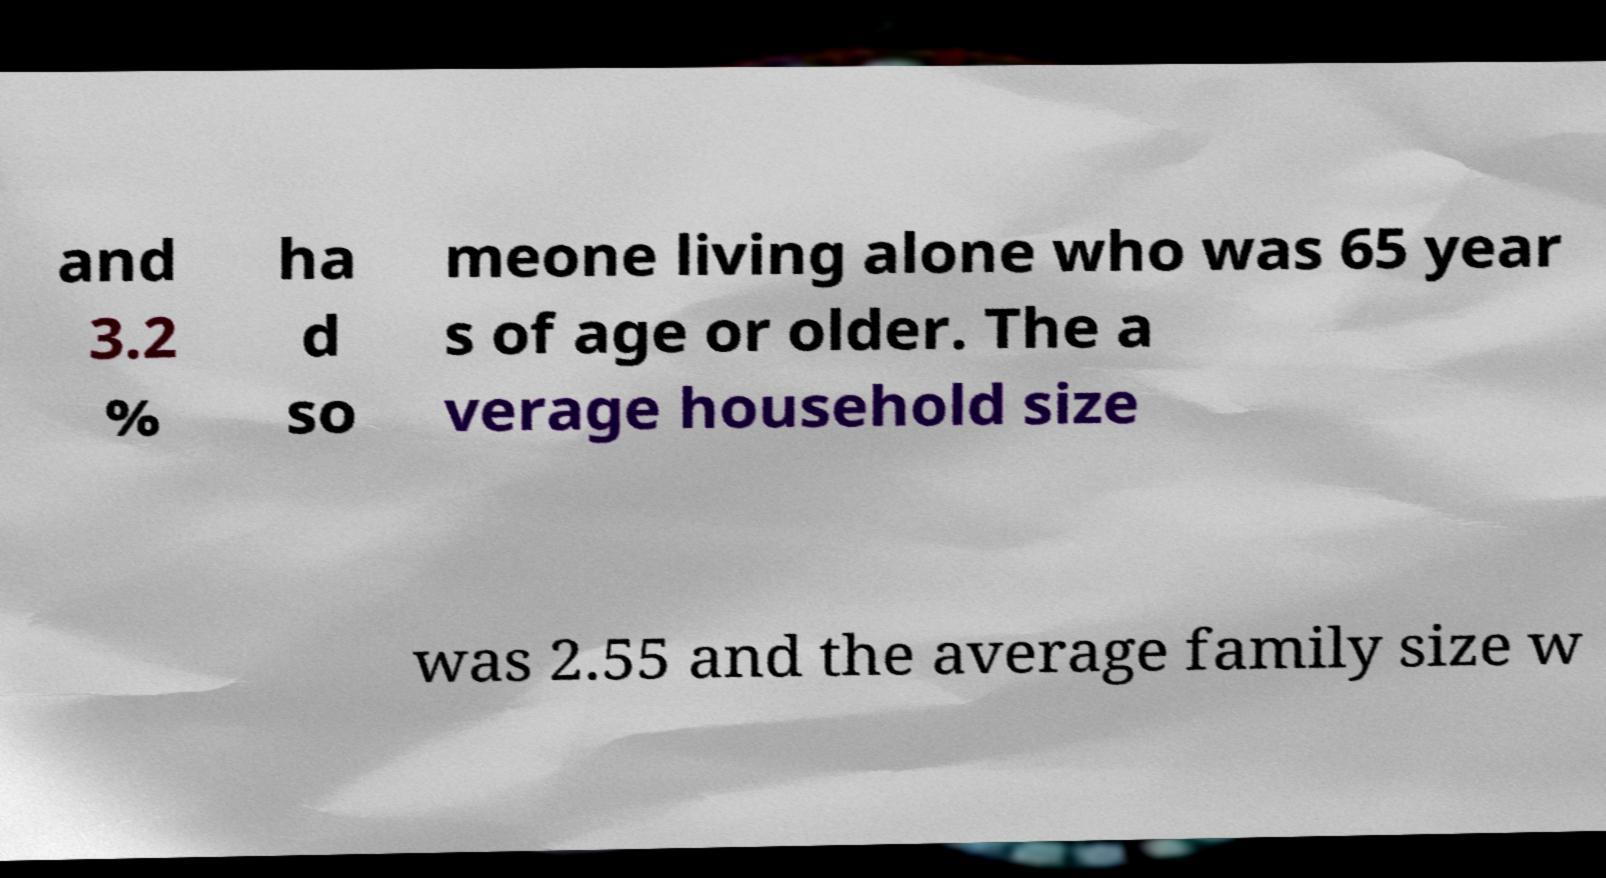Please read and relay the text visible in this image. What does it say? and 3.2 % ha d so meone living alone who was 65 year s of age or older. The a verage household size was 2.55 and the average family size w 